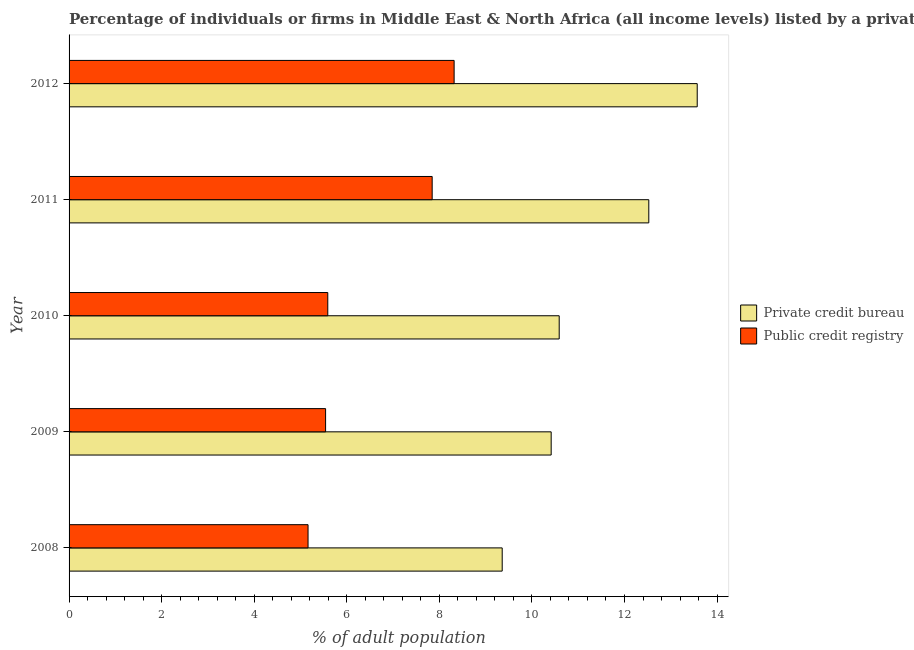How many different coloured bars are there?
Ensure brevity in your answer.  2. Are the number of bars per tick equal to the number of legend labels?
Give a very brief answer. Yes. How many bars are there on the 1st tick from the top?
Ensure brevity in your answer.  2. How many bars are there on the 2nd tick from the bottom?
Give a very brief answer. 2. What is the label of the 5th group of bars from the top?
Ensure brevity in your answer.  2008. In how many cases, is the number of bars for a given year not equal to the number of legend labels?
Make the answer very short. 0. What is the percentage of firms listed by private credit bureau in 2010?
Offer a very short reply. 10.59. Across all years, what is the maximum percentage of firms listed by public credit bureau?
Provide a succinct answer. 8.32. Across all years, what is the minimum percentage of firms listed by public credit bureau?
Offer a terse response. 5.16. In which year was the percentage of firms listed by private credit bureau minimum?
Keep it short and to the point. 2008. What is the total percentage of firms listed by public credit bureau in the graph?
Your response must be concise. 32.46. What is the difference between the percentage of firms listed by private credit bureau in 2008 and that in 2010?
Provide a short and direct response. -1.23. What is the difference between the percentage of firms listed by private credit bureau in 2009 and the percentage of firms listed by public credit bureau in 2010?
Your response must be concise. 4.83. What is the average percentage of firms listed by private credit bureau per year?
Your answer should be very brief. 11.29. In the year 2012, what is the difference between the percentage of firms listed by public credit bureau and percentage of firms listed by private credit bureau?
Offer a terse response. -5.25. Is the percentage of firms listed by public credit bureau in 2010 less than that in 2011?
Ensure brevity in your answer.  Yes. What is the difference between the highest and the second highest percentage of firms listed by public credit bureau?
Make the answer very short. 0.47. What is the difference between the highest and the lowest percentage of firms listed by public credit bureau?
Ensure brevity in your answer.  3.16. What does the 1st bar from the top in 2008 represents?
Offer a terse response. Public credit registry. What does the 2nd bar from the bottom in 2010 represents?
Offer a terse response. Public credit registry. Are all the bars in the graph horizontal?
Your answer should be very brief. Yes. What is the difference between two consecutive major ticks on the X-axis?
Keep it short and to the point. 2. Does the graph contain any zero values?
Offer a terse response. No. Where does the legend appear in the graph?
Offer a terse response. Center right. How many legend labels are there?
Give a very brief answer. 2. What is the title of the graph?
Your response must be concise. Percentage of individuals or firms in Middle East & North Africa (all income levels) listed by a private or public credit bureau. Does "Services" appear as one of the legend labels in the graph?
Offer a very short reply. No. What is the label or title of the X-axis?
Your answer should be compact. % of adult population. What is the % of adult population in Private credit bureau in 2008?
Ensure brevity in your answer.  9.36. What is the % of adult population in Public credit registry in 2008?
Provide a short and direct response. 5.16. What is the % of adult population in Private credit bureau in 2009?
Keep it short and to the point. 10.42. What is the % of adult population in Public credit registry in 2009?
Your answer should be compact. 5.54. What is the % of adult population in Private credit bureau in 2010?
Your answer should be very brief. 10.59. What is the % of adult population of Public credit registry in 2010?
Make the answer very short. 5.59. What is the % of adult population in Private credit bureau in 2011?
Your answer should be very brief. 12.53. What is the % of adult population in Public credit registry in 2011?
Ensure brevity in your answer.  7.84. What is the % of adult population of Private credit bureau in 2012?
Provide a succinct answer. 13.57. What is the % of adult population of Public credit registry in 2012?
Ensure brevity in your answer.  8.32. Across all years, what is the maximum % of adult population of Private credit bureau?
Provide a short and direct response. 13.57. Across all years, what is the maximum % of adult population of Public credit registry?
Ensure brevity in your answer.  8.32. Across all years, what is the minimum % of adult population of Private credit bureau?
Your response must be concise. 9.36. Across all years, what is the minimum % of adult population of Public credit registry?
Provide a short and direct response. 5.16. What is the total % of adult population of Private credit bureau in the graph?
Offer a terse response. 56.46. What is the total % of adult population of Public credit registry in the graph?
Give a very brief answer. 32.46. What is the difference between the % of adult population of Private credit bureau in 2008 and that in 2009?
Your answer should be very brief. -1.06. What is the difference between the % of adult population of Public credit registry in 2008 and that in 2009?
Make the answer very short. -0.38. What is the difference between the % of adult population of Private credit bureau in 2008 and that in 2010?
Make the answer very short. -1.23. What is the difference between the % of adult population of Public credit registry in 2008 and that in 2010?
Offer a terse response. -0.43. What is the difference between the % of adult population of Private credit bureau in 2008 and that in 2011?
Keep it short and to the point. -3.17. What is the difference between the % of adult population in Public credit registry in 2008 and that in 2011?
Provide a succinct answer. -2.68. What is the difference between the % of adult population of Private credit bureau in 2008 and that in 2012?
Your answer should be compact. -4.21. What is the difference between the % of adult population in Public credit registry in 2008 and that in 2012?
Provide a short and direct response. -3.16. What is the difference between the % of adult population of Private credit bureau in 2009 and that in 2010?
Your response must be concise. -0.17. What is the difference between the % of adult population in Public credit registry in 2009 and that in 2010?
Give a very brief answer. -0.05. What is the difference between the % of adult population of Private credit bureau in 2009 and that in 2011?
Provide a short and direct response. -2.11. What is the difference between the % of adult population in Public credit registry in 2009 and that in 2011?
Provide a short and direct response. -2.3. What is the difference between the % of adult population of Private credit bureau in 2009 and that in 2012?
Your response must be concise. -3.16. What is the difference between the % of adult population in Public credit registry in 2009 and that in 2012?
Provide a short and direct response. -2.78. What is the difference between the % of adult population in Private credit bureau in 2010 and that in 2011?
Your answer should be very brief. -1.94. What is the difference between the % of adult population in Public credit registry in 2010 and that in 2011?
Your answer should be compact. -2.26. What is the difference between the % of adult population in Private credit bureau in 2010 and that in 2012?
Offer a very short reply. -2.98. What is the difference between the % of adult population of Public credit registry in 2010 and that in 2012?
Offer a terse response. -2.73. What is the difference between the % of adult population of Private credit bureau in 2011 and that in 2012?
Your response must be concise. -1.05. What is the difference between the % of adult population in Public credit registry in 2011 and that in 2012?
Provide a short and direct response. -0.47. What is the difference between the % of adult population in Private credit bureau in 2008 and the % of adult population in Public credit registry in 2009?
Give a very brief answer. 3.82. What is the difference between the % of adult population in Private credit bureau in 2008 and the % of adult population in Public credit registry in 2010?
Offer a very short reply. 3.77. What is the difference between the % of adult population in Private credit bureau in 2008 and the % of adult population in Public credit registry in 2011?
Make the answer very short. 1.51. What is the difference between the % of adult population in Private credit bureau in 2008 and the % of adult population in Public credit registry in 2012?
Offer a very short reply. 1.04. What is the difference between the % of adult population of Private credit bureau in 2009 and the % of adult population of Public credit registry in 2010?
Your answer should be compact. 4.83. What is the difference between the % of adult population of Private credit bureau in 2009 and the % of adult population of Public credit registry in 2011?
Give a very brief answer. 2.57. What is the difference between the % of adult population of Private credit bureau in 2009 and the % of adult population of Public credit registry in 2012?
Offer a terse response. 2.1. What is the difference between the % of adult population of Private credit bureau in 2010 and the % of adult population of Public credit registry in 2011?
Your response must be concise. 2.74. What is the difference between the % of adult population of Private credit bureau in 2010 and the % of adult population of Public credit registry in 2012?
Your answer should be compact. 2.27. What is the difference between the % of adult population of Private credit bureau in 2011 and the % of adult population of Public credit registry in 2012?
Offer a very short reply. 4.21. What is the average % of adult population of Private credit bureau per year?
Your answer should be very brief. 11.29. What is the average % of adult population of Public credit registry per year?
Your answer should be compact. 6.49. In the year 2008, what is the difference between the % of adult population of Private credit bureau and % of adult population of Public credit registry?
Ensure brevity in your answer.  4.19. In the year 2009, what is the difference between the % of adult population of Private credit bureau and % of adult population of Public credit registry?
Offer a terse response. 4.87. In the year 2010, what is the difference between the % of adult population in Private credit bureau and % of adult population in Public credit registry?
Make the answer very short. 5. In the year 2011, what is the difference between the % of adult population of Private credit bureau and % of adult population of Public credit registry?
Give a very brief answer. 4.68. In the year 2012, what is the difference between the % of adult population of Private credit bureau and % of adult population of Public credit registry?
Make the answer very short. 5.25. What is the ratio of the % of adult population in Private credit bureau in 2008 to that in 2009?
Keep it short and to the point. 0.9. What is the ratio of the % of adult population of Public credit registry in 2008 to that in 2009?
Give a very brief answer. 0.93. What is the ratio of the % of adult population of Private credit bureau in 2008 to that in 2010?
Ensure brevity in your answer.  0.88. What is the ratio of the % of adult population in Public credit registry in 2008 to that in 2010?
Offer a very short reply. 0.92. What is the ratio of the % of adult population of Private credit bureau in 2008 to that in 2011?
Ensure brevity in your answer.  0.75. What is the ratio of the % of adult population in Public credit registry in 2008 to that in 2011?
Provide a succinct answer. 0.66. What is the ratio of the % of adult population in Private credit bureau in 2008 to that in 2012?
Your answer should be compact. 0.69. What is the ratio of the % of adult population in Public credit registry in 2008 to that in 2012?
Provide a succinct answer. 0.62. What is the ratio of the % of adult population in Private credit bureau in 2009 to that in 2010?
Your answer should be compact. 0.98. What is the ratio of the % of adult population of Public credit registry in 2009 to that in 2010?
Ensure brevity in your answer.  0.99. What is the ratio of the % of adult population of Private credit bureau in 2009 to that in 2011?
Provide a succinct answer. 0.83. What is the ratio of the % of adult population of Public credit registry in 2009 to that in 2011?
Your response must be concise. 0.71. What is the ratio of the % of adult population of Private credit bureau in 2009 to that in 2012?
Provide a succinct answer. 0.77. What is the ratio of the % of adult population in Public credit registry in 2009 to that in 2012?
Provide a succinct answer. 0.67. What is the ratio of the % of adult population of Private credit bureau in 2010 to that in 2011?
Make the answer very short. 0.85. What is the ratio of the % of adult population in Public credit registry in 2010 to that in 2011?
Your response must be concise. 0.71. What is the ratio of the % of adult population of Private credit bureau in 2010 to that in 2012?
Give a very brief answer. 0.78. What is the ratio of the % of adult population of Public credit registry in 2010 to that in 2012?
Keep it short and to the point. 0.67. What is the ratio of the % of adult population of Private credit bureau in 2011 to that in 2012?
Offer a very short reply. 0.92. What is the ratio of the % of adult population of Public credit registry in 2011 to that in 2012?
Your answer should be very brief. 0.94. What is the difference between the highest and the second highest % of adult population in Private credit bureau?
Offer a very short reply. 1.05. What is the difference between the highest and the second highest % of adult population of Public credit registry?
Give a very brief answer. 0.47. What is the difference between the highest and the lowest % of adult population of Private credit bureau?
Keep it short and to the point. 4.21. What is the difference between the highest and the lowest % of adult population in Public credit registry?
Provide a short and direct response. 3.16. 